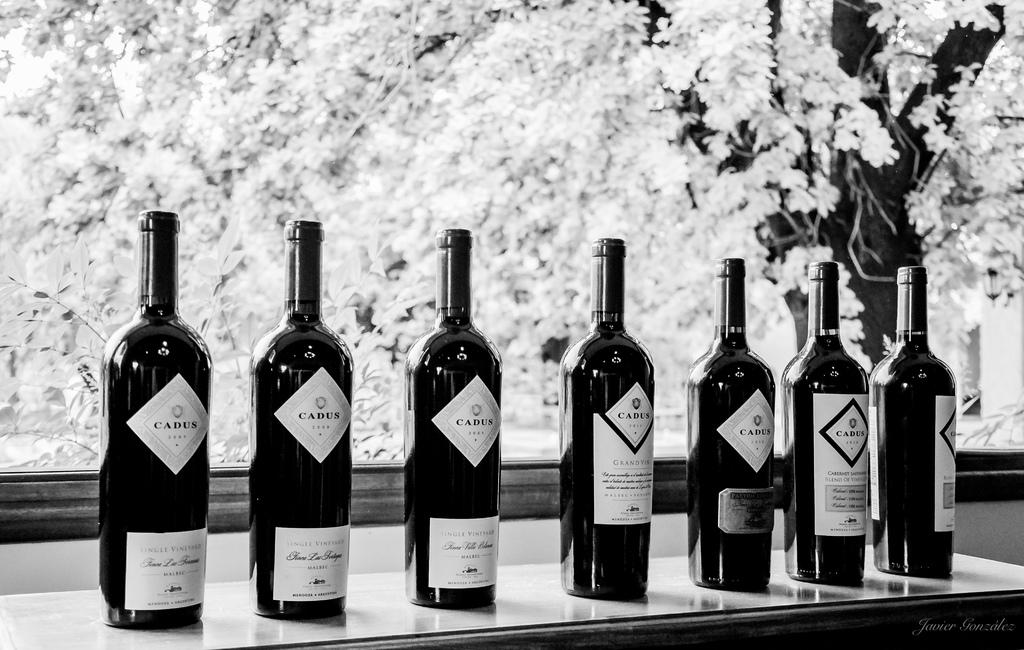Provide a one-sentence caption for the provided image. Seven unopened bottles of Cadus wine sit on a counter. 